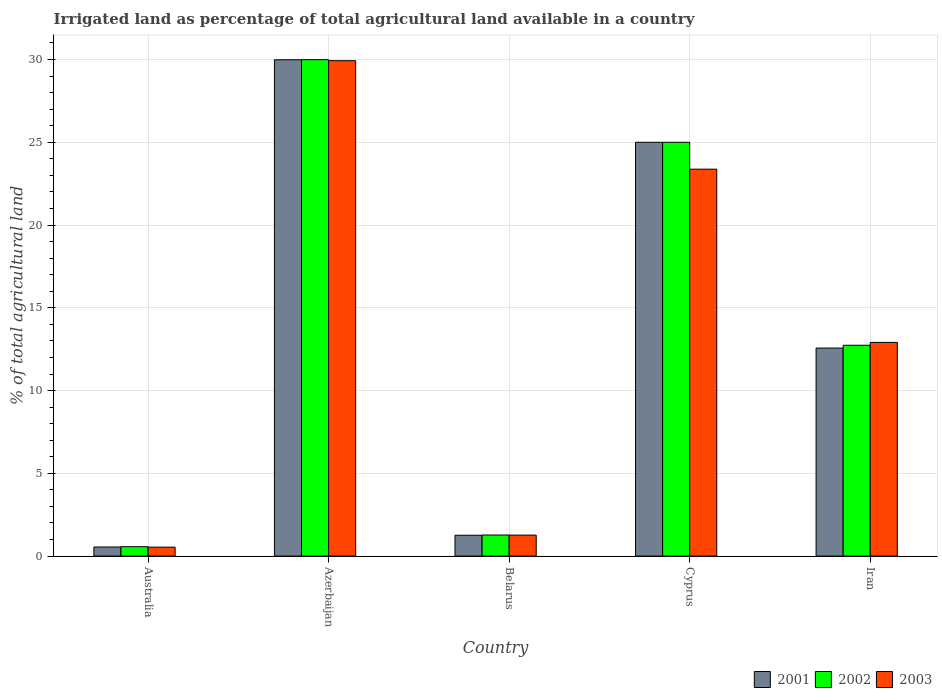How many groups of bars are there?
Offer a very short reply. 5. How many bars are there on the 2nd tick from the right?
Offer a very short reply. 3. What is the label of the 3rd group of bars from the left?
Offer a very short reply. Belarus. In how many cases, is the number of bars for a given country not equal to the number of legend labels?
Provide a short and direct response. 0. What is the percentage of irrigated land in 2003 in Australia?
Provide a short and direct response. 0.54. Across all countries, what is the maximum percentage of irrigated land in 2003?
Keep it short and to the point. 29.93. Across all countries, what is the minimum percentage of irrigated land in 2002?
Provide a short and direct response. 0.57. In which country was the percentage of irrigated land in 2001 maximum?
Offer a very short reply. Azerbaijan. What is the total percentage of irrigated land in 2003 in the graph?
Offer a very short reply. 68.03. What is the difference between the percentage of irrigated land in 2001 in Australia and that in Belarus?
Your answer should be compact. -0.71. What is the difference between the percentage of irrigated land in 2002 in Cyprus and the percentage of irrigated land in 2001 in Iran?
Provide a short and direct response. 12.43. What is the average percentage of irrigated land in 2003 per country?
Offer a very short reply. 13.61. What is the difference between the percentage of irrigated land of/in 2003 and percentage of irrigated land of/in 2001 in Australia?
Make the answer very short. -0.01. In how many countries, is the percentage of irrigated land in 2002 greater than 17 %?
Ensure brevity in your answer.  2. What is the ratio of the percentage of irrigated land in 2001 in Australia to that in Cyprus?
Make the answer very short. 0.02. Is the difference between the percentage of irrigated land in 2003 in Azerbaijan and Belarus greater than the difference between the percentage of irrigated land in 2001 in Azerbaijan and Belarus?
Offer a very short reply. No. What is the difference between the highest and the second highest percentage of irrigated land in 2001?
Offer a very short reply. 12.43. What is the difference between the highest and the lowest percentage of irrigated land in 2001?
Offer a very short reply. 29.44. Are all the bars in the graph horizontal?
Your response must be concise. No. How many countries are there in the graph?
Your response must be concise. 5. What is the difference between two consecutive major ticks on the Y-axis?
Make the answer very short. 5. Are the values on the major ticks of Y-axis written in scientific E-notation?
Ensure brevity in your answer.  No. Does the graph contain grids?
Your response must be concise. Yes. Where does the legend appear in the graph?
Give a very brief answer. Bottom right. How many legend labels are there?
Offer a terse response. 3. What is the title of the graph?
Make the answer very short. Irrigated land as percentage of total agricultural land available in a country. Does "1977" appear as one of the legend labels in the graph?
Make the answer very short. No. What is the label or title of the Y-axis?
Make the answer very short. % of total agricultural land. What is the % of total agricultural land in 2001 in Australia?
Ensure brevity in your answer.  0.55. What is the % of total agricultural land of 2002 in Australia?
Your answer should be compact. 0.57. What is the % of total agricultural land in 2003 in Australia?
Your response must be concise. 0.54. What is the % of total agricultural land in 2001 in Azerbaijan?
Keep it short and to the point. 29.99. What is the % of total agricultural land of 2002 in Azerbaijan?
Your answer should be compact. 29.99. What is the % of total agricultural land of 2003 in Azerbaijan?
Your response must be concise. 29.93. What is the % of total agricultural land in 2001 in Belarus?
Offer a very short reply. 1.26. What is the % of total agricultural land of 2002 in Belarus?
Provide a succinct answer. 1.27. What is the % of total agricultural land of 2003 in Belarus?
Give a very brief answer. 1.27. What is the % of total agricultural land in 2001 in Cyprus?
Make the answer very short. 25. What is the % of total agricultural land of 2003 in Cyprus?
Ensure brevity in your answer.  23.38. What is the % of total agricultural land of 2001 in Iran?
Make the answer very short. 12.57. What is the % of total agricultural land of 2002 in Iran?
Your answer should be very brief. 12.74. What is the % of total agricultural land of 2003 in Iran?
Keep it short and to the point. 12.91. Across all countries, what is the maximum % of total agricultural land in 2001?
Your answer should be compact. 29.99. Across all countries, what is the maximum % of total agricultural land in 2002?
Give a very brief answer. 29.99. Across all countries, what is the maximum % of total agricultural land of 2003?
Provide a succinct answer. 29.93. Across all countries, what is the minimum % of total agricultural land in 2001?
Offer a terse response. 0.55. Across all countries, what is the minimum % of total agricultural land of 2002?
Your answer should be compact. 0.57. Across all countries, what is the minimum % of total agricultural land of 2003?
Offer a terse response. 0.54. What is the total % of total agricultural land in 2001 in the graph?
Offer a very short reply. 69.36. What is the total % of total agricultural land in 2002 in the graph?
Ensure brevity in your answer.  69.57. What is the total % of total agricultural land in 2003 in the graph?
Your response must be concise. 68.03. What is the difference between the % of total agricultural land of 2001 in Australia and that in Azerbaijan?
Offer a terse response. -29.44. What is the difference between the % of total agricultural land in 2002 in Australia and that in Azerbaijan?
Offer a very short reply. -29.42. What is the difference between the % of total agricultural land in 2003 in Australia and that in Azerbaijan?
Your answer should be compact. -29.39. What is the difference between the % of total agricultural land in 2001 in Australia and that in Belarus?
Offer a very short reply. -0.71. What is the difference between the % of total agricultural land of 2002 in Australia and that in Belarus?
Your answer should be compact. -0.7. What is the difference between the % of total agricultural land of 2003 in Australia and that in Belarus?
Make the answer very short. -0.73. What is the difference between the % of total agricultural land of 2001 in Australia and that in Cyprus?
Give a very brief answer. -24.45. What is the difference between the % of total agricultural land of 2002 in Australia and that in Cyprus?
Your response must be concise. -24.43. What is the difference between the % of total agricultural land in 2003 in Australia and that in Cyprus?
Your response must be concise. -22.84. What is the difference between the % of total agricultural land in 2001 in Australia and that in Iran?
Your answer should be very brief. -12.02. What is the difference between the % of total agricultural land of 2002 in Australia and that in Iran?
Keep it short and to the point. -12.17. What is the difference between the % of total agricultural land in 2003 in Australia and that in Iran?
Your response must be concise. -12.37. What is the difference between the % of total agricultural land in 2001 in Azerbaijan and that in Belarus?
Offer a terse response. 28.73. What is the difference between the % of total agricultural land of 2002 in Azerbaijan and that in Belarus?
Offer a terse response. 28.72. What is the difference between the % of total agricultural land in 2003 in Azerbaijan and that in Belarus?
Your answer should be very brief. 28.66. What is the difference between the % of total agricultural land of 2001 in Azerbaijan and that in Cyprus?
Offer a terse response. 4.99. What is the difference between the % of total agricultural land in 2002 in Azerbaijan and that in Cyprus?
Give a very brief answer. 4.99. What is the difference between the % of total agricultural land of 2003 in Azerbaijan and that in Cyprus?
Provide a short and direct response. 6.55. What is the difference between the % of total agricultural land in 2001 in Azerbaijan and that in Iran?
Give a very brief answer. 17.42. What is the difference between the % of total agricultural land in 2002 in Azerbaijan and that in Iran?
Give a very brief answer. 17.25. What is the difference between the % of total agricultural land of 2003 in Azerbaijan and that in Iran?
Provide a succinct answer. 17.02. What is the difference between the % of total agricultural land in 2001 in Belarus and that in Cyprus?
Your response must be concise. -23.74. What is the difference between the % of total agricultural land in 2002 in Belarus and that in Cyprus?
Provide a short and direct response. -23.73. What is the difference between the % of total agricultural land of 2003 in Belarus and that in Cyprus?
Ensure brevity in your answer.  -22.11. What is the difference between the % of total agricultural land in 2001 in Belarus and that in Iran?
Provide a succinct answer. -11.31. What is the difference between the % of total agricultural land in 2002 in Belarus and that in Iran?
Offer a terse response. -11.46. What is the difference between the % of total agricultural land in 2003 in Belarus and that in Iran?
Provide a short and direct response. -11.64. What is the difference between the % of total agricultural land in 2001 in Cyprus and that in Iran?
Provide a short and direct response. 12.43. What is the difference between the % of total agricultural land of 2002 in Cyprus and that in Iran?
Offer a terse response. 12.26. What is the difference between the % of total agricultural land in 2003 in Cyprus and that in Iran?
Offer a very short reply. 10.47. What is the difference between the % of total agricultural land of 2001 in Australia and the % of total agricultural land of 2002 in Azerbaijan?
Your response must be concise. -29.44. What is the difference between the % of total agricultural land of 2001 in Australia and the % of total agricultural land of 2003 in Azerbaijan?
Provide a short and direct response. -29.38. What is the difference between the % of total agricultural land in 2002 in Australia and the % of total agricultural land in 2003 in Azerbaijan?
Keep it short and to the point. -29.36. What is the difference between the % of total agricultural land of 2001 in Australia and the % of total agricultural land of 2002 in Belarus?
Give a very brief answer. -0.72. What is the difference between the % of total agricultural land of 2001 in Australia and the % of total agricultural land of 2003 in Belarus?
Keep it short and to the point. -0.72. What is the difference between the % of total agricultural land of 2002 in Australia and the % of total agricultural land of 2003 in Belarus?
Keep it short and to the point. -0.7. What is the difference between the % of total agricultural land of 2001 in Australia and the % of total agricultural land of 2002 in Cyprus?
Make the answer very short. -24.45. What is the difference between the % of total agricultural land in 2001 in Australia and the % of total agricultural land in 2003 in Cyprus?
Keep it short and to the point. -22.83. What is the difference between the % of total agricultural land of 2002 in Australia and the % of total agricultural land of 2003 in Cyprus?
Your response must be concise. -22.81. What is the difference between the % of total agricultural land in 2001 in Australia and the % of total agricultural land in 2002 in Iran?
Provide a short and direct response. -12.19. What is the difference between the % of total agricultural land of 2001 in Australia and the % of total agricultural land of 2003 in Iran?
Offer a very short reply. -12.36. What is the difference between the % of total agricultural land of 2002 in Australia and the % of total agricultural land of 2003 in Iran?
Offer a very short reply. -12.34. What is the difference between the % of total agricultural land in 2001 in Azerbaijan and the % of total agricultural land in 2002 in Belarus?
Ensure brevity in your answer.  28.71. What is the difference between the % of total agricultural land in 2001 in Azerbaijan and the % of total agricultural land in 2003 in Belarus?
Keep it short and to the point. 28.72. What is the difference between the % of total agricultural land of 2002 in Azerbaijan and the % of total agricultural land of 2003 in Belarus?
Give a very brief answer. 28.72. What is the difference between the % of total agricultural land in 2001 in Azerbaijan and the % of total agricultural land in 2002 in Cyprus?
Offer a very short reply. 4.99. What is the difference between the % of total agricultural land of 2001 in Azerbaijan and the % of total agricultural land of 2003 in Cyprus?
Give a very brief answer. 6.61. What is the difference between the % of total agricultural land of 2002 in Azerbaijan and the % of total agricultural land of 2003 in Cyprus?
Provide a succinct answer. 6.61. What is the difference between the % of total agricultural land of 2001 in Azerbaijan and the % of total agricultural land of 2002 in Iran?
Keep it short and to the point. 17.25. What is the difference between the % of total agricultural land in 2001 in Azerbaijan and the % of total agricultural land in 2003 in Iran?
Offer a terse response. 17.08. What is the difference between the % of total agricultural land in 2002 in Azerbaijan and the % of total agricultural land in 2003 in Iran?
Your answer should be compact. 17.08. What is the difference between the % of total agricultural land in 2001 in Belarus and the % of total agricultural land in 2002 in Cyprus?
Offer a very short reply. -23.74. What is the difference between the % of total agricultural land of 2001 in Belarus and the % of total agricultural land of 2003 in Cyprus?
Keep it short and to the point. -22.12. What is the difference between the % of total agricultural land of 2002 in Belarus and the % of total agricultural land of 2003 in Cyprus?
Offer a terse response. -22.1. What is the difference between the % of total agricultural land in 2001 in Belarus and the % of total agricultural land in 2002 in Iran?
Your response must be concise. -11.48. What is the difference between the % of total agricultural land of 2001 in Belarus and the % of total agricultural land of 2003 in Iran?
Provide a succinct answer. -11.65. What is the difference between the % of total agricultural land of 2002 in Belarus and the % of total agricultural land of 2003 in Iran?
Make the answer very short. -11.64. What is the difference between the % of total agricultural land in 2001 in Cyprus and the % of total agricultural land in 2002 in Iran?
Offer a very short reply. 12.26. What is the difference between the % of total agricultural land of 2001 in Cyprus and the % of total agricultural land of 2003 in Iran?
Ensure brevity in your answer.  12.09. What is the difference between the % of total agricultural land in 2002 in Cyprus and the % of total agricultural land in 2003 in Iran?
Provide a succinct answer. 12.09. What is the average % of total agricultural land in 2001 per country?
Offer a very short reply. 13.87. What is the average % of total agricultural land in 2002 per country?
Ensure brevity in your answer.  13.91. What is the average % of total agricultural land of 2003 per country?
Your response must be concise. 13.61. What is the difference between the % of total agricultural land of 2001 and % of total agricultural land of 2002 in Australia?
Ensure brevity in your answer.  -0.02. What is the difference between the % of total agricultural land in 2001 and % of total agricultural land in 2003 in Australia?
Make the answer very short. 0.01. What is the difference between the % of total agricultural land in 2002 and % of total agricultural land in 2003 in Australia?
Keep it short and to the point. 0.03. What is the difference between the % of total agricultural land in 2001 and % of total agricultural land in 2002 in Azerbaijan?
Your response must be concise. -0. What is the difference between the % of total agricultural land of 2001 and % of total agricultural land of 2003 in Azerbaijan?
Provide a short and direct response. 0.06. What is the difference between the % of total agricultural land in 2002 and % of total agricultural land in 2003 in Azerbaijan?
Offer a very short reply. 0.06. What is the difference between the % of total agricultural land in 2001 and % of total agricultural land in 2002 in Belarus?
Offer a terse response. -0.01. What is the difference between the % of total agricultural land of 2001 and % of total agricultural land of 2003 in Belarus?
Offer a terse response. -0.01. What is the difference between the % of total agricultural land in 2002 and % of total agricultural land in 2003 in Belarus?
Your response must be concise. 0.01. What is the difference between the % of total agricultural land in 2001 and % of total agricultural land in 2003 in Cyprus?
Give a very brief answer. 1.62. What is the difference between the % of total agricultural land of 2002 and % of total agricultural land of 2003 in Cyprus?
Make the answer very short. 1.62. What is the difference between the % of total agricultural land in 2001 and % of total agricultural land in 2002 in Iran?
Ensure brevity in your answer.  -0.17. What is the difference between the % of total agricultural land in 2001 and % of total agricultural land in 2003 in Iran?
Your response must be concise. -0.34. What is the difference between the % of total agricultural land in 2002 and % of total agricultural land in 2003 in Iran?
Your answer should be very brief. -0.17. What is the ratio of the % of total agricultural land in 2001 in Australia to that in Azerbaijan?
Your answer should be very brief. 0.02. What is the ratio of the % of total agricultural land in 2002 in Australia to that in Azerbaijan?
Your answer should be compact. 0.02. What is the ratio of the % of total agricultural land in 2003 in Australia to that in Azerbaijan?
Your response must be concise. 0.02. What is the ratio of the % of total agricultural land of 2001 in Australia to that in Belarus?
Give a very brief answer. 0.44. What is the ratio of the % of total agricultural land in 2002 in Australia to that in Belarus?
Make the answer very short. 0.45. What is the ratio of the % of total agricultural land in 2003 in Australia to that in Belarus?
Your answer should be compact. 0.43. What is the ratio of the % of total agricultural land of 2001 in Australia to that in Cyprus?
Your response must be concise. 0.02. What is the ratio of the % of total agricultural land in 2002 in Australia to that in Cyprus?
Provide a short and direct response. 0.02. What is the ratio of the % of total agricultural land in 2003 in Australia to that in Cyprus?
Your response must be concise. 0.02. What is the ratio of the % of total agricultural land in 2001 in Australia to that in Iran?
Keep it short and to the point. 0.04. What is the ratio of the % of total agricultural land of 2002 in Australia to that in Iran?
Make the answer very short. 0.04. What is the ratio of the % of total agricultural land in 2003 in Australia to that in Iran?
Keep it short and to the point. 0.04. What is the ratio of the % of total agricultural land of 2001 in Azerbaijan to that in Belarus?
Your response must be concise. 23.8. What is the ratio of the % of total agricultural land in 2002 in Azerbaijan to that in Belarus?
Provide a succinct answer. 23.54. What is the ratio of the % of total agricultural land in 2003 in Azerbaijan to that in Belarus?
Ensure brevity in your answer.  23.59. What is the ratio of the % of total agricultural land in 2001 in Azerbaijan to that in Cyprus?
Your response must be concise. 1.2. What is the ratio of the % of total agricultural land of 2002 in Azerbaijan to that in Cyprus?
Offer a very short reply. 1.2. What is the ratio of the % of total agricultural land in 2003 in Azerbaijan to that in Cyprus?
Your answer should be compact. 1.28. What is the ratio of the % of total agricultural land of 2001 in Azerbaijan to that in Iran?
Make the answer very short. 2.39. What is the ratio of the % of total agricultural land of 2002 in Azerbaijan to that in Iran?
Keep it short and to the point. 2.35. What is the ratio of the % of total agricultural land in 2003 in Azerbaijan to that in Iran?
Keep it short and to the point. 2.32. What is the ratio of the % of total agricultural land of 2001 in Belarus to that in Cyprus?
Offer a very short reply. 0.05. What is the ratio of the % of total agricultural land in 2002 in Belarus to that in Cyprus?
Your answer should be compact. 0.05. What is the ratio of the % of total agricultural land in 2003 in Belarus to that in Cyprus?
Provide a succinct answer. 0.05. What is the ratio of the % of total agricultural land of 2001 in Belarus to that in Iran?
Provide a short and direct response. 0.1. What is the ratio of the % of total agricultural land of 2003 in Belarus to that in Iran?
Your response must be concise. 0.1. What is the ratio of the % of total agricultural land in 2001 in Cyprus to that in Iran?
Ensure brevity in your answer.  1.99. What is the ratio of the % of total agricultural land in 2002 in Cyprus to that in Iran?
Your response must be concise. 1.96. What is the ratio of the % of total agricultural land of 2003 in Cyprus to that in Iran?
Your response must be concise. 1.81. What is the difference between the highest and the second highest % of total agricultural land in 2001?
Offer a very short reply. 4.99. What is the difference between the highest and the second highest % of total agricultural land of 2002?
Your answer should be compact. 4.99. What is the difference between the highest and the second highest % of total agricultural land of 2003?
Your response must be concise. 6.55. What is the difference between the highest and the lowest % of total agricultural land in 2001?
Your response must be concise. 29.44. What is the difference between the highest and the lowest % of total agricultural land in 2002?
Ensure brevity in your answer.  29.42. What is the difference between the highest and the lowest % of total agricultural land in 2003?
Give a very brief answer. 29.39. 